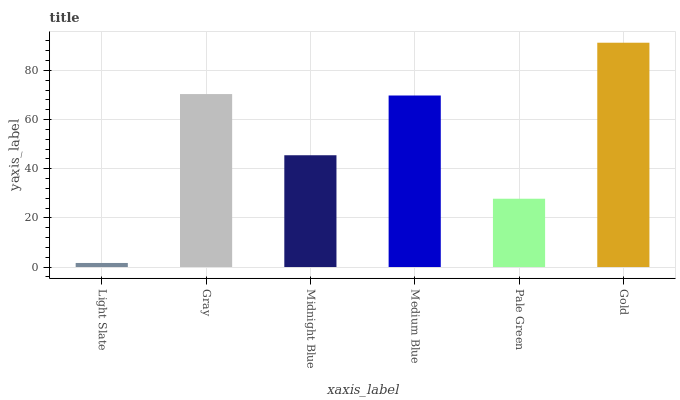Is Light Slate the minimum?
Answer yes or no. Yes. Is Gold the maximum?
Answer yes or no. Yes. Is Gray the minimum?
Answer yes or no. No. Is Gray the maximum?
Answer yes or no. No. Is Gray greater than Light Slate?
Answer yes or no. Yes. Is Light Slate less than Gray?
Answer yes or no. Yes. Is Light Slate greater than Gray?
Answer yes or no. No. Is Gray less than Light Slate?
Answer yes or no. No. Is Medium Blue the high median?
Answer yes or no. Yes. Is Midnight Blue the low median?
Answer yes or no. Yes. Is Gray the high median?
Answer yes or no. No. Is Medium Blue the low median?
Answer yes or no. No. 